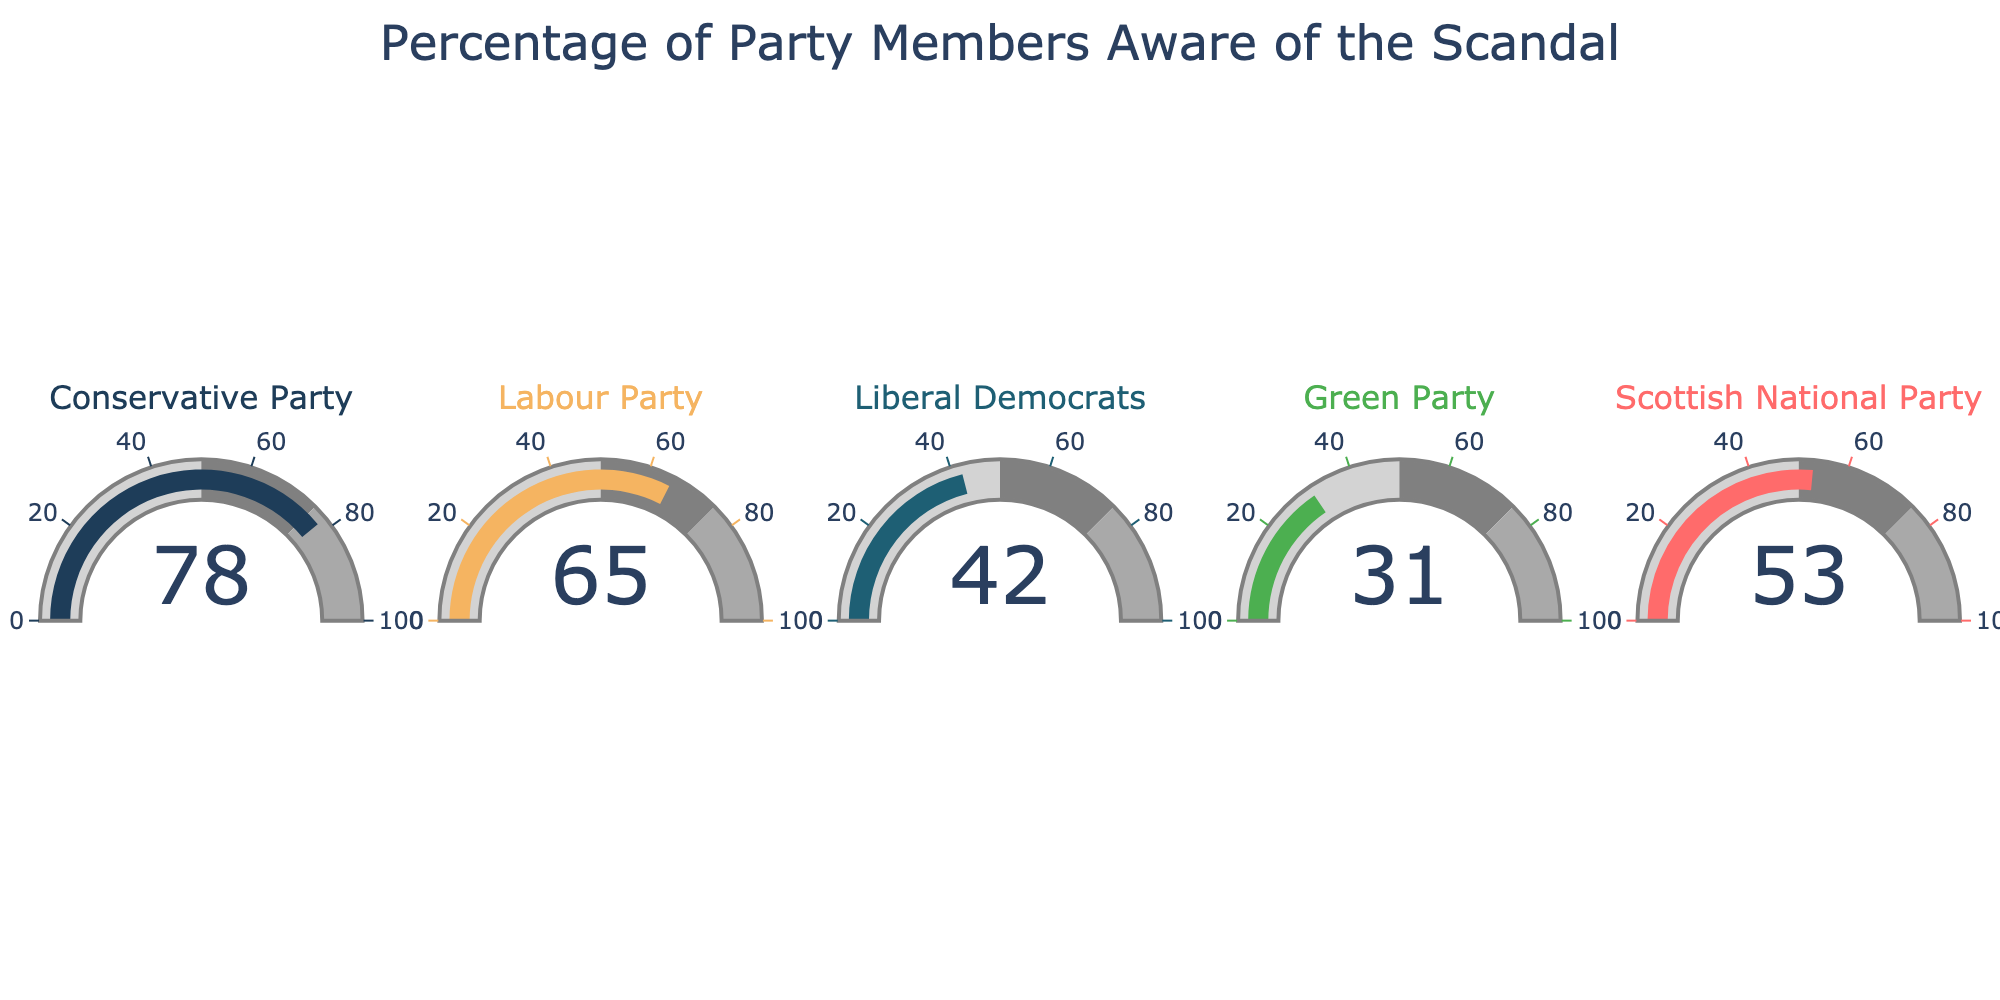What is the title of the figure? The title is displayed at the top of the figure and is clearly labeled.
Answer: "Percentage of Party Members Aware of the Scandal" How many political parties are represented in the figure? The figure shows different gauges, each representing a political party. By counting the number of separate gauges, we find there are five.
Answer: Five What is the aware percentage of the Conservative Party? Referencing the gauge labeled "Conservative Party" shows a value of 78%.
Answer: 78% Which political party has the lowest percentage of members aware of the scandal? By comparing the values on each gauge, we find that the Green Party has the lowest at 31%.
Answer: Green Party What is the average aware percentage across all political parties? Add the aware percentages of each party and then divide by the number of parties: (78 + 65 + 42 + 31 + 53) / 5 = 53.8
Answer: 53.8 How much higher is the aware percentage of the Conservative Party compared to the Liberal Democrats? Subtract the aware percentage of the Liberal Democrats from that of the Conservative Party: 78 - 42 = 36
Answer: 36 Which parties have an aware percentage greater than 50%? Consider the gauges with values greater than 50%. These are the Conservative Party (78%), Labour Party (65%), and Scottish National Party (53%).
Answer: Conservative Party, Labour Party, Scottish National Party What is the difference in aware percentage between the party with the highest percentage and the party with the lowest percentage? Subtract the lowest aware percentage (31% for Green Party) from the highest aware percentage (78% for Conservative Party): 78 - 31 = 47
Answer: 47 By how much does the Labour Party's aware percentage exceed the Green Party's aware percentage? Subtract the aware percentage of the Green Party from that of the Labour Party: 65 - 31 = 34
Answer: 34 What is the median aware percentage of the political parties? Sort the aware percentages: [31, 42, 53, 65, 78]. The median is the middle value, which is 53.
Answer: 53 